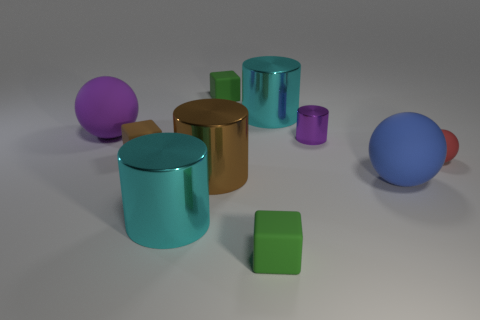What is the shape of the rubber object that is the same color as the small metallic cylinder?
Ensure brevity in your answer.  Sphere. What number of rubber things are the same color as the tiny shiny object?
Keep it short and to the point. 1. There is a big ball that is on the left side of the small shiny cylinder; is it the same color as the tiny shiny cylinder?
Offer a very short reply. Yes. There is a large blue rubber thing; how many small green rubber cubes are to the right of it?
Provide a short and direct response. 0. Is the number of big yellow shiny blocks greater than the number of purple matte balls?
Give a very brief answer. No. There is a matte ball that is the same color as the small metallic cylinder; what size is it?
Your response must be concise. Large. There is a rubber thing that is to the right of the tiny brown object and behind the small red matte object; what is its size?
Your answer should be compact. Small. The large cyan cylinder that is in front of the large matte thing on the left side of the big cyan metal thing behind the large brown shiny thing is made of what material?
Give a very brief answer. Metal. What material is the big sphere that is the same color as the tiny shiny thing?
Give a very brief answer. Rubber. Is the color of the tiny cylinder on the left side of the blue rubber object the same as the large ball that is left of the large brown metallic thing?
Make the answer very short. Yes. 